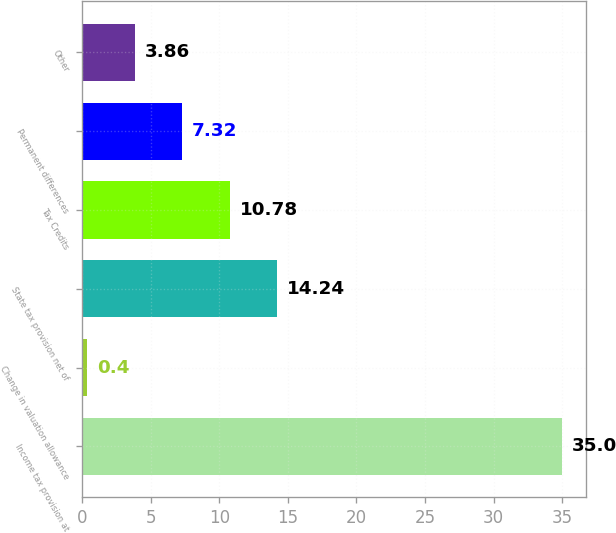Convert chart to OTSL. <chart><loc_0><loc_0><loc_500><loc_500><bar_chart><fcel>Income tax provision at<fcel>Change in valuation allowance<fcel>State tax provision net of<fcel>Tax Credits<fcel>Permanent differences<fcel>Other<nl><fcel>35<fcel>0.4<fcel>14.24<fcel>10.78<fcel>7.32<fcel>3.86<nl></chart> 